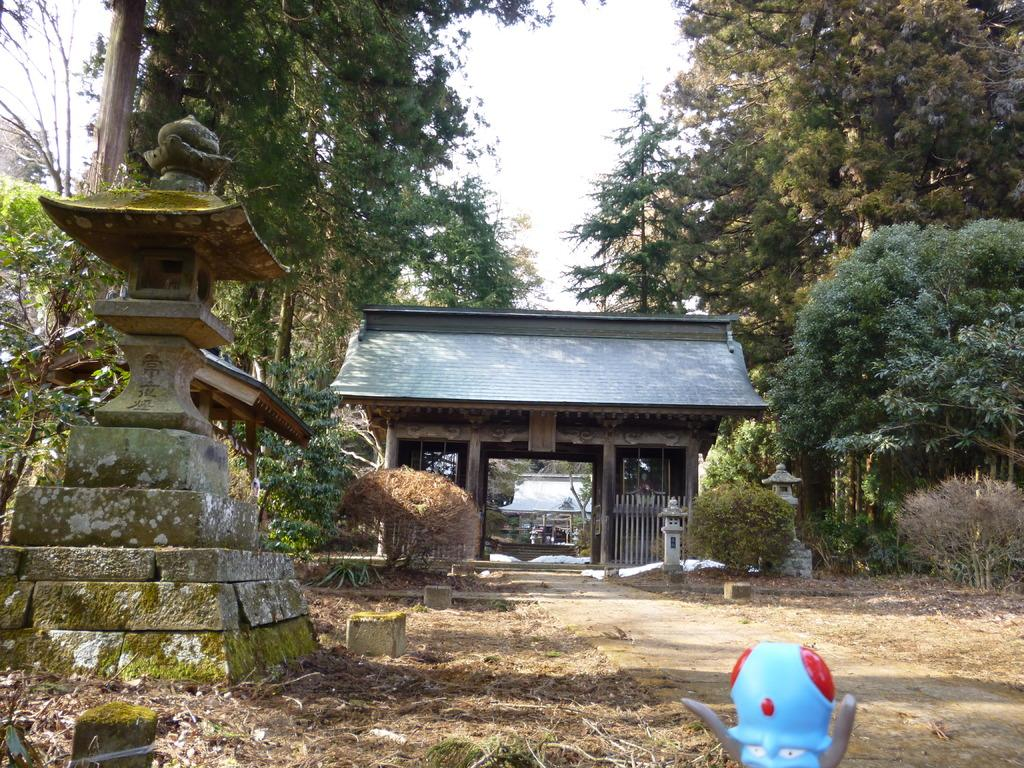What is the main structure located at the front of the image? There is a concrete pillar in the front of the image. What type of gate can be seen in the image? There is an arch gate with roof tiles in the image. What type of vegetation is present on both sides of the image? There are trees on both sides of the image. Can you see your aunt sitting by the lake in the image? There is no lake or your aunt present in the image. How many family members are visible in the image? There is no reference to family members in the image; it features a concrete pillar, an arch gate, and trees. 